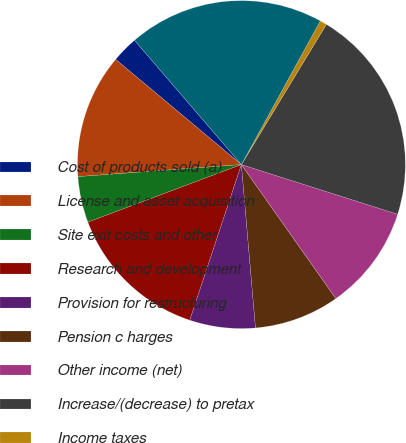<chart> <loc_0><loc_0><loc_500><loc_500><pie_chart><fcel>Cost of products sold (a)<fcel>License and asset acquisition<fcel>Site exit costs and other<fcel>Research and development<fcel>Provision for restructuring<fcel>Pension c harges<fcel>Other income (net)<fcel>Increase/(decrease) to pretax<fcel>Income taxes<fcel>Increase/(decrease) to net<nl><fcel>2.61%<fcel>12.26%<fcel>4.54%<fcel>14.19%<fcel>6.47%<fcel>8.4%<fcel>10.33%<fcel>21.23%<fcel>0.68%<fcel>19.3%<nl></chart> 